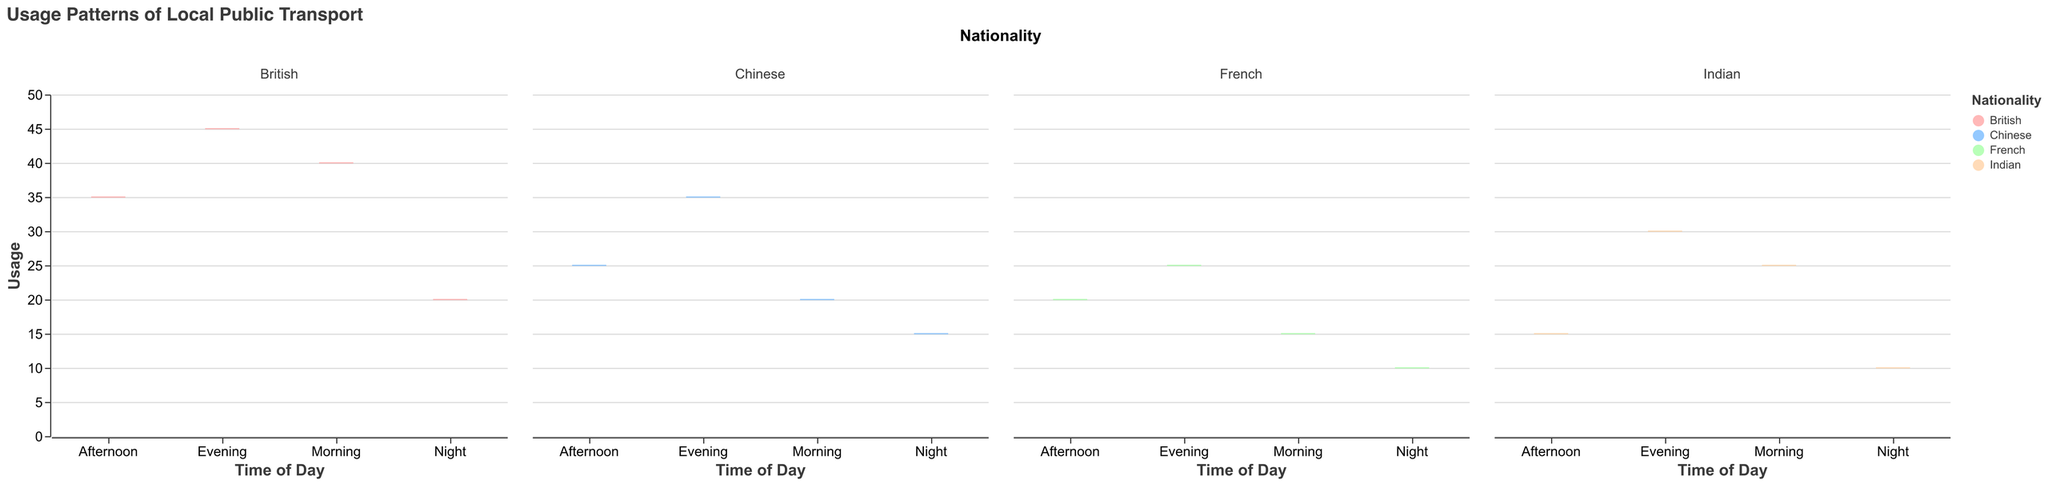What is the title of the plot? The title of the plot is written at the top and it reads "Usage Patterns of Local Public Transport."
Answer: Usage Patterns of Local Public Transport How many nationalities are represented in the plot? The plot has different columns for each nationality that include Indian, British, Chinese, and French.
Answer: 4 Which nationality has the highest usage of public transport in the morning? Looking at the box plots for each nationality under the "Morning" category, the British nationality has the highest usage with a value of 40.
Answer: British What is the median usage for the Indian nationality in the evening? The Indian evening usage is indicated by the median line inside the evening box for Indians, which is at 30.
Answer: 30 Compare the evening usage between Indian and British nationalities. Which one is higher? Observing the evening usage boxes for both nationalities, the British nationality's evening usage is 45, while the Indian is 30, so British is higher.
Answer: British Which time of day has the least public transport usage for the Chinese nationality? Reviewing the box plots for Chinese usage across different times, "Morning" has the lowest usage value at 20.
Answer: Morning Is there any nationality that has an equal transport usage at any two different times of day? By checking the box plots for all nationalities, none of them have equal usage values at any two different times of the day.
Answer: No What is the average public transport usage for the French nationality across all times of the day? To find the average, sum the usage for French (15 + 20 + 25 + 10 = 70), and divide by 4 (70 / 4).
Answer: 17.5 Which time of day shows the highest variability in public transport usage among all nationalities? Observing the spread of the box plots for all times of the day, the "Evening" category has the largest range, especially noticeable in British with highs and lows between 25 and 40.
Answer: Evening Which nationality uses the local public transport the least at night? By checking the values of the night box plots, both Indian and French nationalities have the least usage with a value of 10.
Answer: Indian and French 